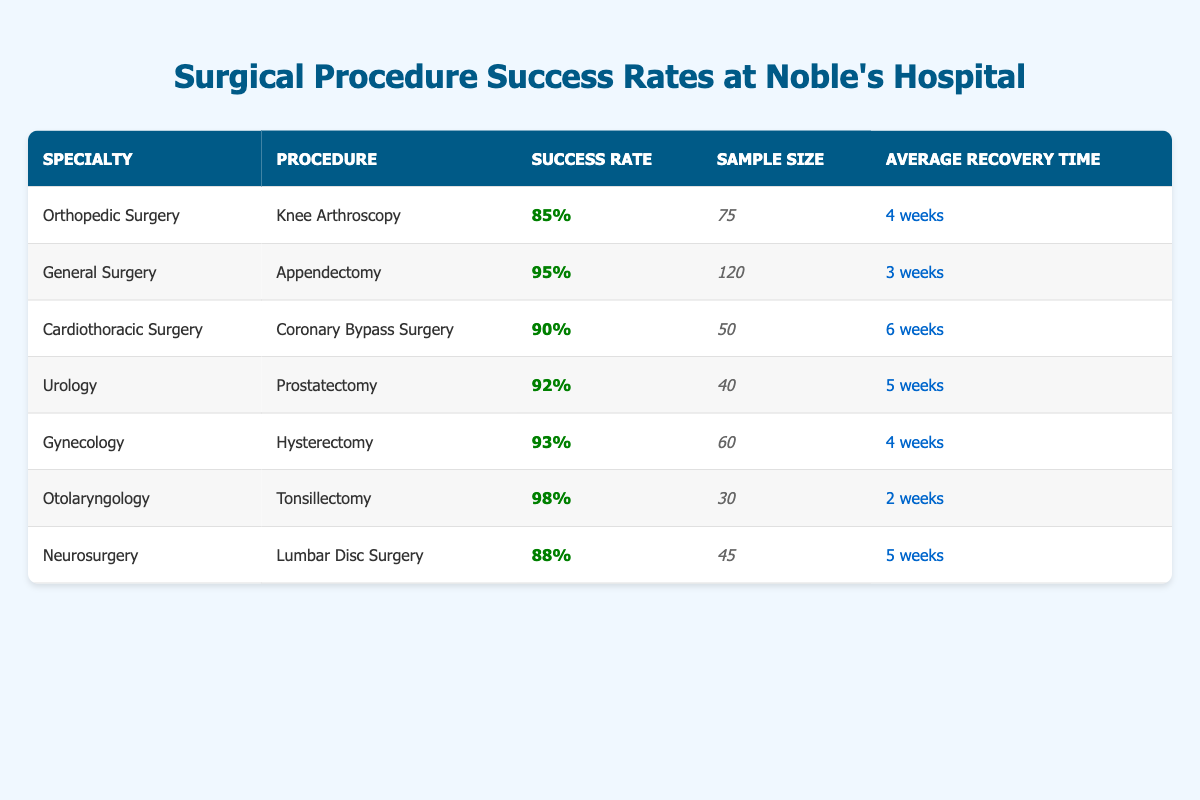What is the success rate of the Tonsillectomy procedure? The success rate for the Tonsillectomy procedure under Otolaryngology specialty is found in the table, listed as 98%.
Answer: 98% Which specialty has the highest success rate according to the table? By comparing the success rates across all specialties, Otolaryngology (Tonsillectomy) has the highest success rate at 98%.
Answer: Otolaryngology What is the average recovery time for procedures with a success rate above 90%? The procedures with a success rate above 90% are Appendectomy (3 weeks), Prostatectomy (5 weeks), Hysterectomy (4 weeks), and Tonsillectomy (2 weeks). The average recovery time is calculated as (3 + 5 + 4 + 2) weeks / 4 = 3.5 weeks.
Answer: 3.5 weeks Is the success rate of Knee Arthroscopy greater than 90%? The success rate for Knee Arthroscopy under Orthopedic Surgery is 85%, which is not greater than 90%.
Answer: No How many total samples were involved in procedures from the Urology and Gynecology specialties? The sample sizes for Urology (Prostatectomy) is 40 and for Gynecology (Hysterectomy) is 60. Adding these gives a total: 40 + 60 = 100.
Answer: 100 